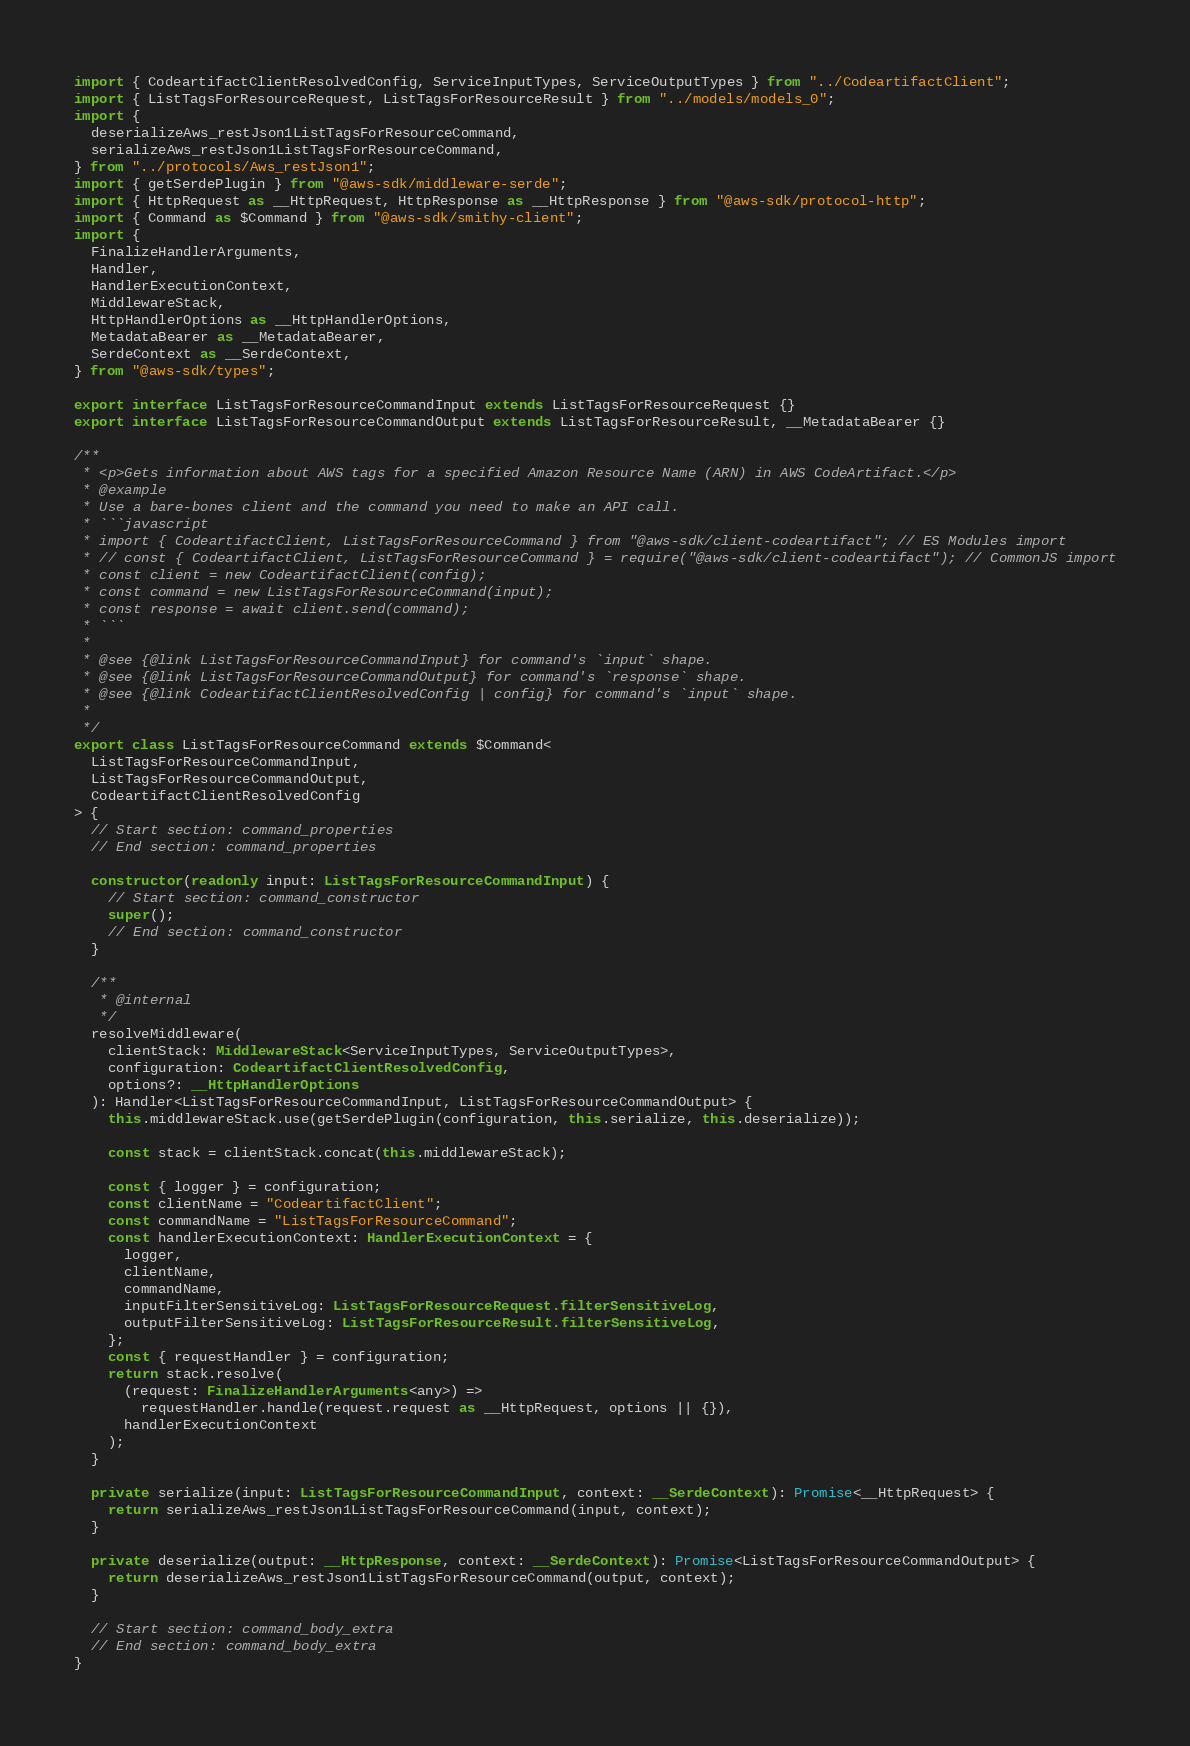<code> <loc_0><loc_0><loc_500><loc_500><_TypeScript_>import { CodeartifactClientResolvedConfig, ServiceInputTypes, ServiceOutputTypes } from "../CodeartifactClient";
import { ListTagsForResourceRequest, ListTagsForResourceResult } from "../models/models_0";
import {
  deserializeAws_restJson1ListTagsForResourceCommand,
  serializeAws_restJson1ListTagsForResourceCommand,
} from "../protocols/Aws_restJson1";
import { getSerdePlugin } from "@aws-sdk/middleware-serde";
import { HttpRequest as __HttpRequest, HttpResponse as __HttpResponse } from "@aws-sdk/protocol-http";
import { Command as $Command } from "@aws-sdk/smithy-client";
import {
  FinalizeHandlerArguments,
  Handler,
  HandlerExecutionContext,
  MiddlewareStack,
  HttpHandlerOptions as __HttpHandlerOptions,
  MetadataBearer as __MetadataBearer,
  SerdeContext as __SerdeContext,
} from "@aws-sdk/types";

export interface ListTagsForResourceCommandInput extends ListTagsForResourceRequest {}
export interface ListTagsForResourceCommandOutput extends ListTagsForResourceResult, __MetadataBearer {}

/**
 * <p>Gets information about AWS tags for a specified Amazon Resource Name (ARN) in AWS CodeArtifact.</p>
 * @example
 * Use a bare-bones client and the command you need to make an API call.
 * ```javascript
 * import { CodeartifactClient, ListTagsForResourceCommand } from "@aws-sdk/client-codeartifact"; // ES Modules import
 * // const { CodeartifactClient, ListTagsForResourceCommand } = require("@aws-sdk/client-codeartifact"); // CommonJS import
 * const client = new CodeartifactClient(config);
 * const command = new ListTagsForResourceCommand(input);
 * const response = await client.send(command);
 * ```
 *
 * @see {@link ListTagsForResourceCommandInput} for command's `input` shape.
 * @see {@link ListTagsForResourceCommandOutput} for command's `response` shape.
 * @see {@link CodeartifactClientResolvedConfig | config} for command's `input` shape.
 *
 */
export class ListTagsForResourceCommand extends $Command<
  ListTagsForResourceCommandInput,
  ListTagsForResourceCommandOutput,
  CodeartifactClientResolvedConfig
> {
  // Start section: command_properties
  // End section: command_properties

  constructor(readonly input: ListTagsForResourceCommandInput) {
    // Start section: command_constructor
    super();
    // End section: command_constructor
  }

  /**
   * @internal
   */
  resolveMiddleware(
    clientStack: MiddlewareStack<ServiceInputTypes, ServiceOutputTypes>,
    configuration: CodeartifactClientResolvedConfig,
    options?: __HttpHandlerOptions
  ): Handler<ListTagsForResourceCommandInput, ListTagsForResourceCommandOutput> {
    this.middlewareStack.use(getSerdePlugin(configuration, this.serialize, this.deserialize));

    const stack = clientStack.concat(this.middlewareStack);

    const { logger } = configuration;
    const clientName = "CodeartifactClient";
    const commandName = "ListTagsForResourceCommand";
    const handlerExecutionContext: HandlerExecutionContext = {
      logger,
      clientName,
      commandName,
      inputFilterSensitiveLog: ListTagsForResourceRequest.filterSensitiveLog,
      outputFilterSensitiveLog: ListTagsForResourceResult.filterSensitiveLog,
    };
    const { requestHandler } = configuration;
    return stack.resolve(
      (request: FinalizeHandlerArguments<any>) =>
        requestHandler.handle(request.request as __HttpRequest, options || {}),
      handlerExecutionContext
    );
  }

  private serialize(input: ListTagsForResourceCommandInput, context: __SerdeContext): Promise<__HttpRequest> {
    return serializeAws_restJson1ListTagsForResourceCommand(input, context);
  }

  private deserialize(output: __HttpResponse, context: __SerdeContext): Promise<ListTagsForResourceCommandOutput> {
    return deserializeAws_restJson1ListTagsForResourceCommand(output, context);
  }

  // Start section: command_body_extra
  // End section: command_body_extra
}
</code> 